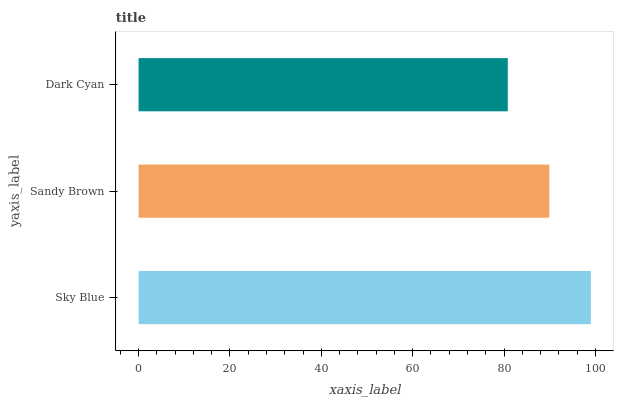Is Dark Cyan the minimum?
Answer yes or no. Yes. Is Sky Blue the maximum?
Answer yes or no. Yes. Is Sandy Brown the minimum?
Answer yes or no. No. Is Sandy Brown the maximum?
Answer yes or no. No. Is Sky Blue greater than Sandy Brown?
Answer yes or no. Yes. Is Sandy Brown less than Sky Blue?
Answer yes or no. Yes. Is Sandy Brown greater than Sky Blue?
Answer yes or no. No. Is Sky Blue less than Sandy Brown?
Answer yes or no. No. Is Sandy Brown the high median?
Answer yes or no. Yes. Is Sandy Brown the low median?
Answer yes or no. Yes. Is Sky Blue the high median?
Answer yes or no. No. Is Dark Cyan the low median?
Answer yes or no. No. 